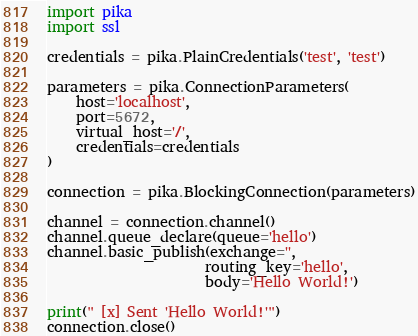Convert code to text. <code><loc_0><loc_0><loc_500><loc_500><_Python_>import pika
import ssl

credentials = pika.PlainCredentials('test', 'test')

parameters = pika.ConnectionParameters(
    host='localhost',
    port=5672,
    virtual_host='/',
    credentials=credentials
)

connection = pika.BlockingConnection(parameters)

channel = connection.channel()
channel.queue_declare(queue='hello')
channel.basic_publish(exchange='',
                      routing_key='hello',
                      body='Hello World!')

print(" [x] Sent 'Hello World!'")
connection.close()

</code> 